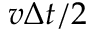Convert formula to latex. <formula><loc_0><loc_0><loc_500><loc_500>v \Delta t / 2</formula> 